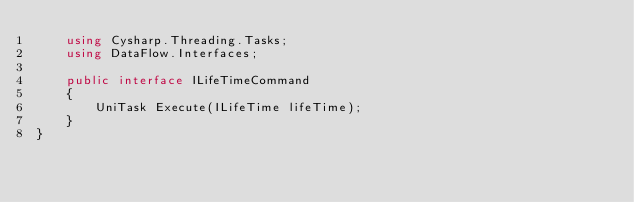Convert code to text. <code><loc_0><loc_0><loc_500><loc_500><_C#_>    using Cysharp.Threading.Tasks;
    using DataFlow.Interfaces;

    public interface ILifeTimeCommand
    {
        UniTask Execute(ILifeTime lifeTime);
    }
}</code> 